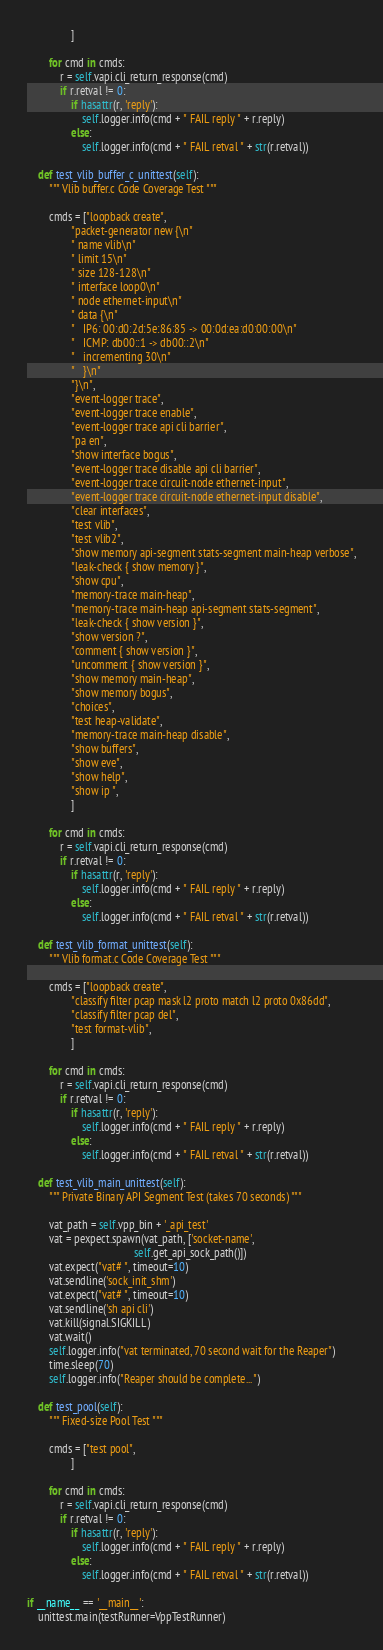Convert code to text. <code><loc_0><loc_0><loc_500><loc_500><_Python_>                ]

        for cmd in cmds:
            r = self.vapi.cli_return_response(cmd)
            if r.retval != 0:
                if hasattr(r, 'reply'):
                    self.logger.info(cmd + " FAIL reply " + r.reply)
                else:
                    self.logger.info(cmd + " FAIL retval " + str(r.retval))

    def test_vlib_buffer_c_unittest(self):
        """ Vlib buffer.c Code Coverage Test """

        cmds = ["loopback create",
                "packet-generator new {\n"
                " name vlib\n"
                " limit 15\n"
                " size 128-128\n"
                " interface loop0\n"
                " node ethernet-input\n"
                " data {\n"
                "   IP6: 00:d0:2d:5e:86:85 -> 00:0d:ea:d0:00:00\n"
                "   ICMP: db00::1 -> db00::2\n"
                "   incrementing 30\n"
                "   }\n"
                "}\n",
                "event-logger trace",
                "event-logger trace enable",
                "event-logger trace api cli barrier",
                "pa en",
                "show interface bogus",
                "event-logger trace disable api cli barrier",
                "event-logger trace circuit-node ethernet-input",
                "event-logger trace circuit-node ethernet-input disable",
                "clear interfaces",
                "test vlib",
                "test vlib2",
                "show memory api-segment stats-segment main-heap verbose",
                "leak-check { show memory }",
                "show cpu",
                "memory-trace main-heap",
                "memory-trace main-heap api-segment stats-segment",
                "leak-check { show version }",
                "show version ?",
                "comment { show version }",
                "uncomment { show version }",
                "show memory main-heap",
                "show memory bogus",
                "choices",
                "test heap-validate",
                "memory-trace main-heap disable",
                "show buffers",
                "show eve",
                "show help",
                "show ip ",
                ]

        for cmd in cmds:
            r = self.vapi.cli_return_response(cmd)
            if r.retval != 0:
                if hasattr(r, 'reply'):
                    self.logger.info(cmd + " FAIL reply " + r.reply)
                else:
                    self.logger.info(cmd + " FAIL retval " + str(r.retval))

    def test_vlib_format_unittest(self):
        """ Vlib format.c Code Coverage Test """

        cmds = ["loopback create",
                "classify filter pcap mask l2 proto match l2 proto 0x86dd",
                "classify filter pcap del",
                "test format-vlib",
                ]

        for cmd in cmds:
            r = self.vapi.cli_return_response(cmd)
            if r.retval != 0:
                if hasattr(r, 'reply'):
                    self.logger.info(cmd + " FAIL reply " + r.reply)
                else:
                    self.logger.info(cmd + " FAIL retval " + str(r.retval))

    def test_vlib_main_unittest(self):
        """ Private Binary API Segment Test (takes 70 seconds) """

        vat_path = self.vpp_bin + '_api_test'
        vat = pexpect.spawn(vat_path, ['socket-name',
                                       self.get_api_sock_path()])
        vat.expect("vat# ", timeout=10)
        vat.sendline('sock_init_shm')
        vat.expect("vat# ", timeout=10)
        vat.sendline('sh api cli')
        vat.kill(signal.SIGKILL)
        vat.wait()
        self.logger.info("vat terminated, 70 second wait for the Reaper")
        time.sleep(70)
        self.logger.info("Reaper should be complete...")

    def test_pool(self):
        """ Fixed-size Pool Test """

        cmds = ["test pool",
                ]

        for cmd in cmds:
            r = self.vapi.cli_return_response(cmd)
            if r.retval != 0:
                if hasattr(r, 'reply'):
                    self.logger.info(cmd + " FAIL reply " + r.reply)
                else:
                    self.logger.info(cmd + " FAIL retval " + str(r.retval))

if __name__ == '__main__':
    unittest.main(testRunner=VppTestRunner)
</code> 